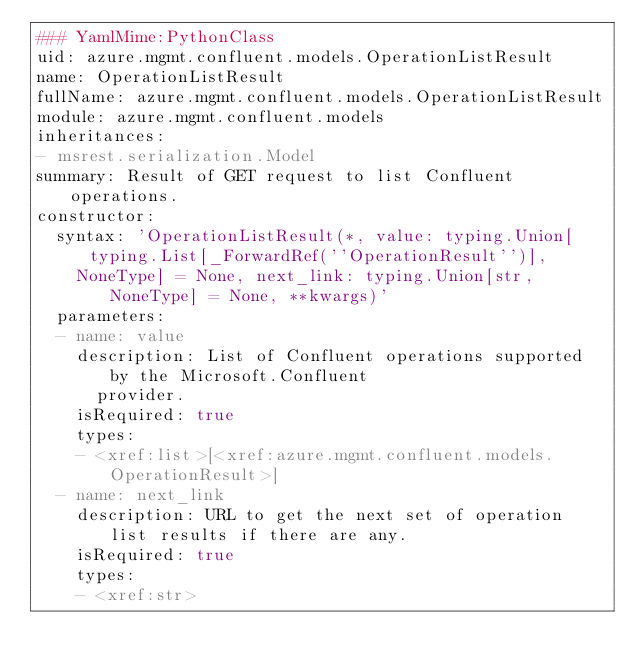<code> <loc_0><loc_0><loc_500><loc_500><_YAML_>### YamlMime:PythonClass
uid: azure.mgmt.confluent.models.OperationListResult
name: OperationListResult
fullName: azure.mgmt.confluent.models.OperationListResult
module: azure.mgmt.confluent.models
inheritances:
- msrest.serialization.Model
summary: Result of GET request to list Confluent operations.
constructor:
  syntax: 'OperationListResult(*, value: typing.Union[typing.List[_ForwardRef(''OperationResult'')],
    NoneType] = None, next_link: typing.Union[str, NoneType] = None, **kwargs)'
  parameters:
  - name: value
    description: List of Confluent operations supported by the Microsoft.Confluent
      provider.
    isRequired: true
    types:
    - <xref:list>[<xref:azure.mgmt.confluent.models.OperationResult>]
  - name: next_link
    description: URL to get the next set of operation list results if there are any.
    isRequired: true
    types:
    - <xref:str>
</code> 